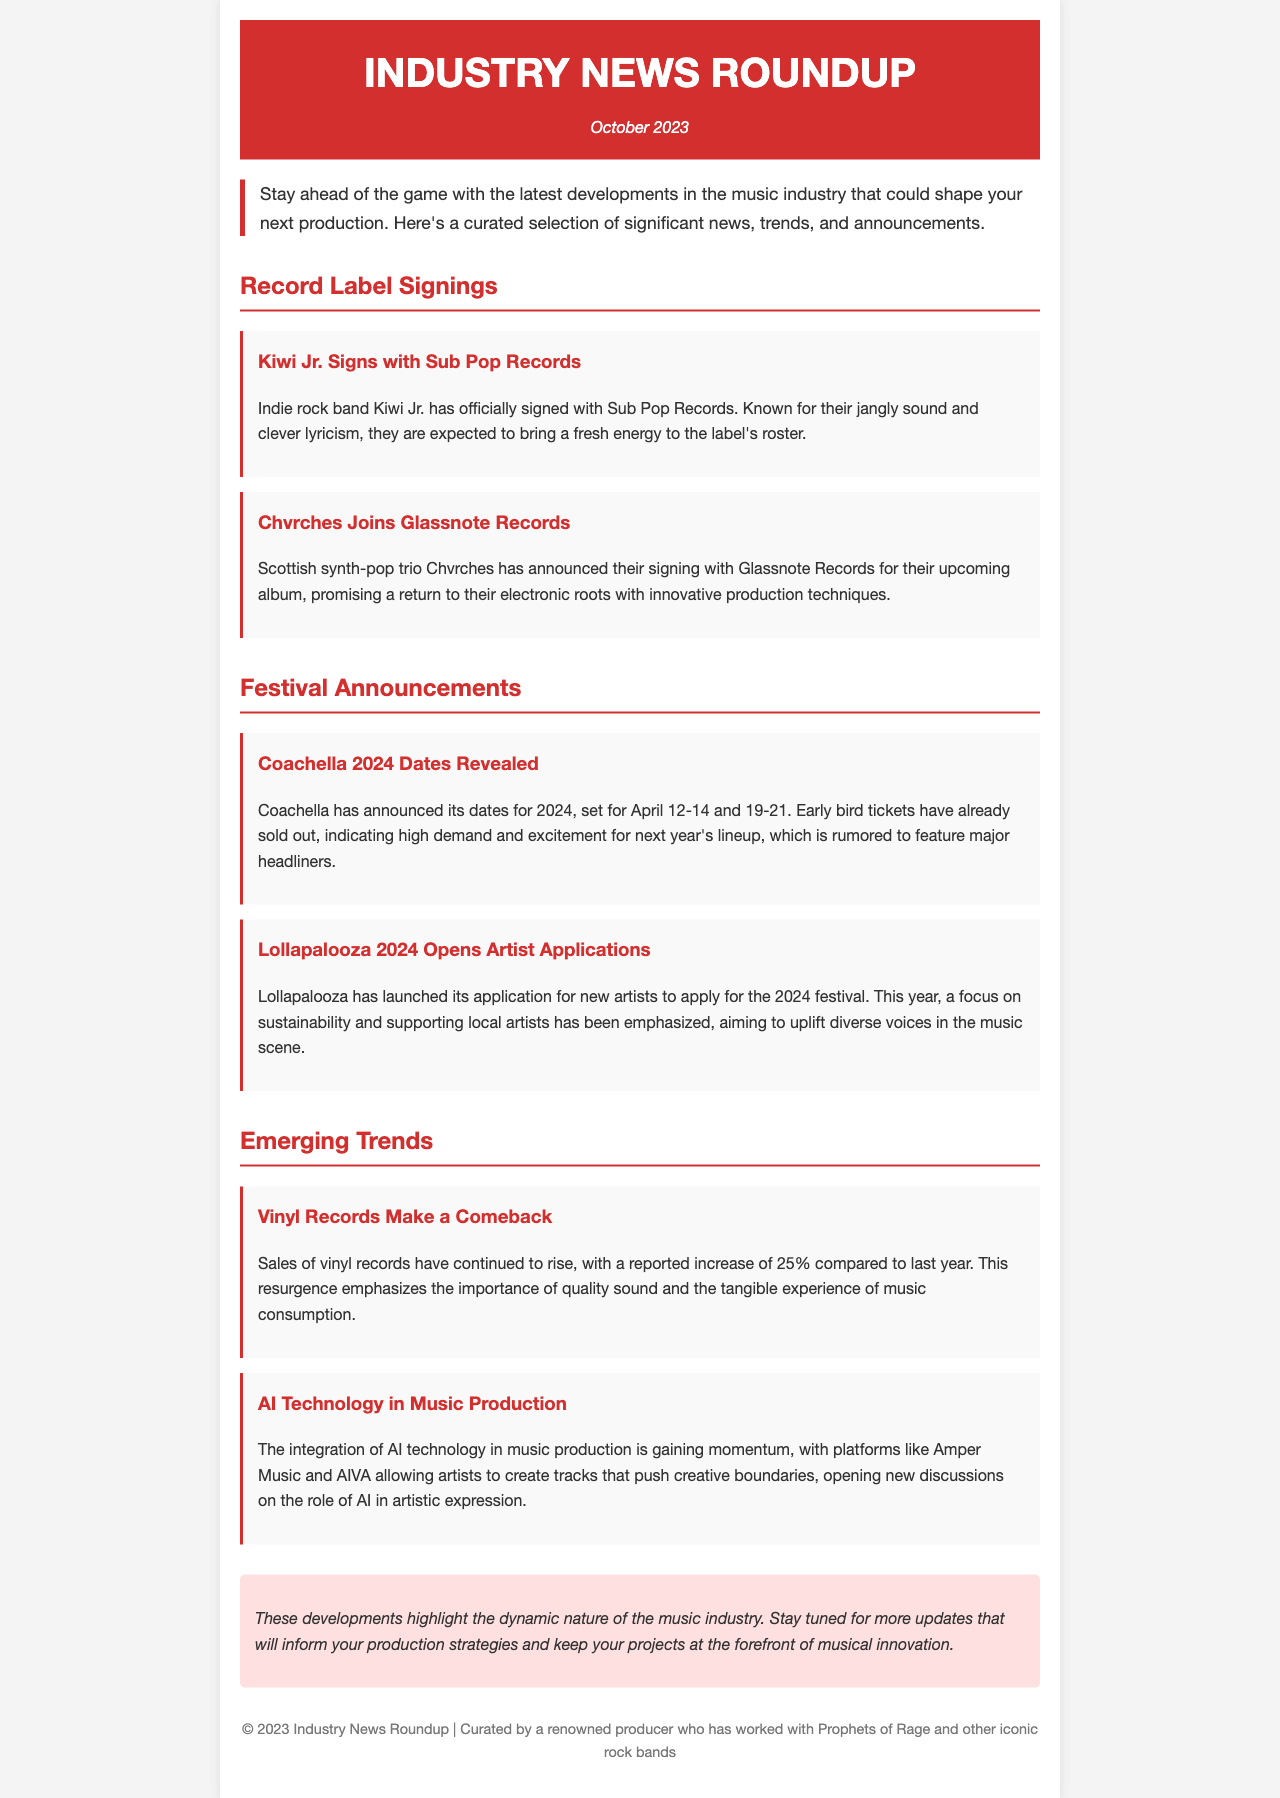What band signed with Sub Pop Records? The document states that Kiwi Jr. has signed with Sub Pop Records.
Answer: Kiwi Jr What is the trend in vinyl records sales? The document mentions a reported increase of 25% in sales of vinyl records compared to last year.
Answer: 25% When will Coachella 2024 take place? The dates for Coachella 2024 are revealed as April 12-14 and 19-21.
Answer: April 12-14 and 19-21 Which festival has opened applications for new artists? The document indicates that Lollapalooza has launched its application for new artists for the 2024 festival.
Answer: Lollapalooza What technology is gaining momentum in music production? It states that AI technology is gaining momentum in music production.
Answer: AI technology What is emphasized by Lollapalooza in 2024? The document highlights a focus on sustainability and supporting local artists at Lollapalooza.
Answer: Sustainability and supporting local artists Which record label did Chvrches sign with? It is stated that Chvrches has signed with Glassnote Records for their upcoming album.
Answer: Glassnote Records What percentage increase is noted in vinyl record sales? The document notes a 25% increase in vinyl record sales compared to last year.
Answer: 25% 